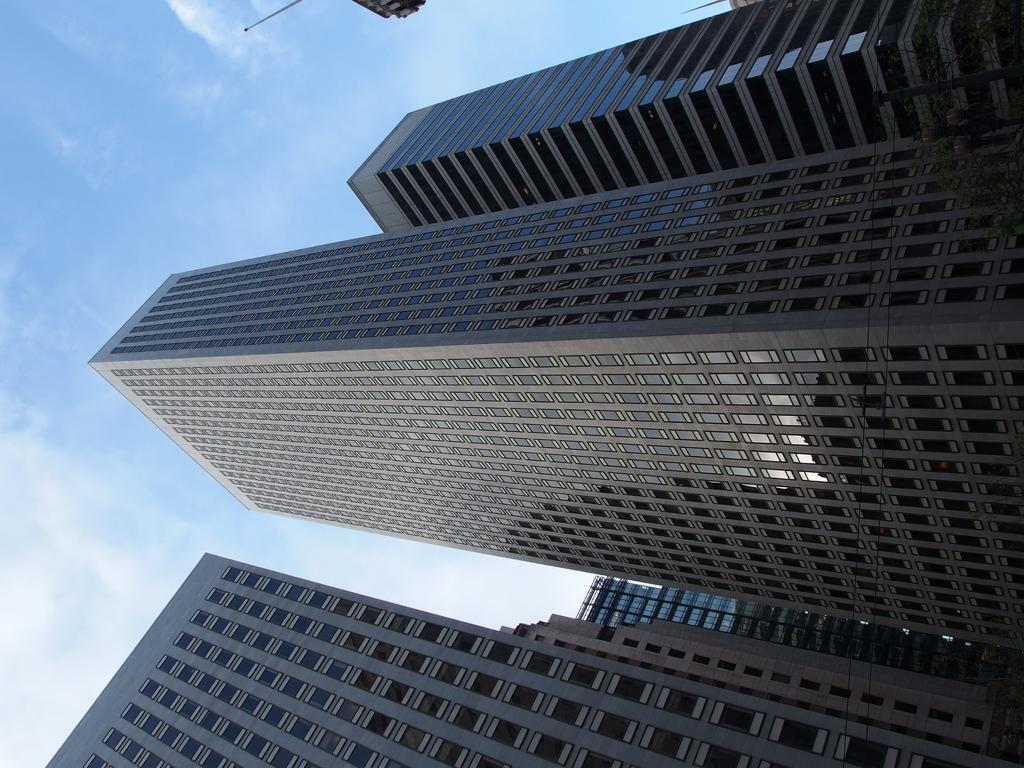Can you describe this image briefly? In this image we can see buildings and sky with clouds in the background. 